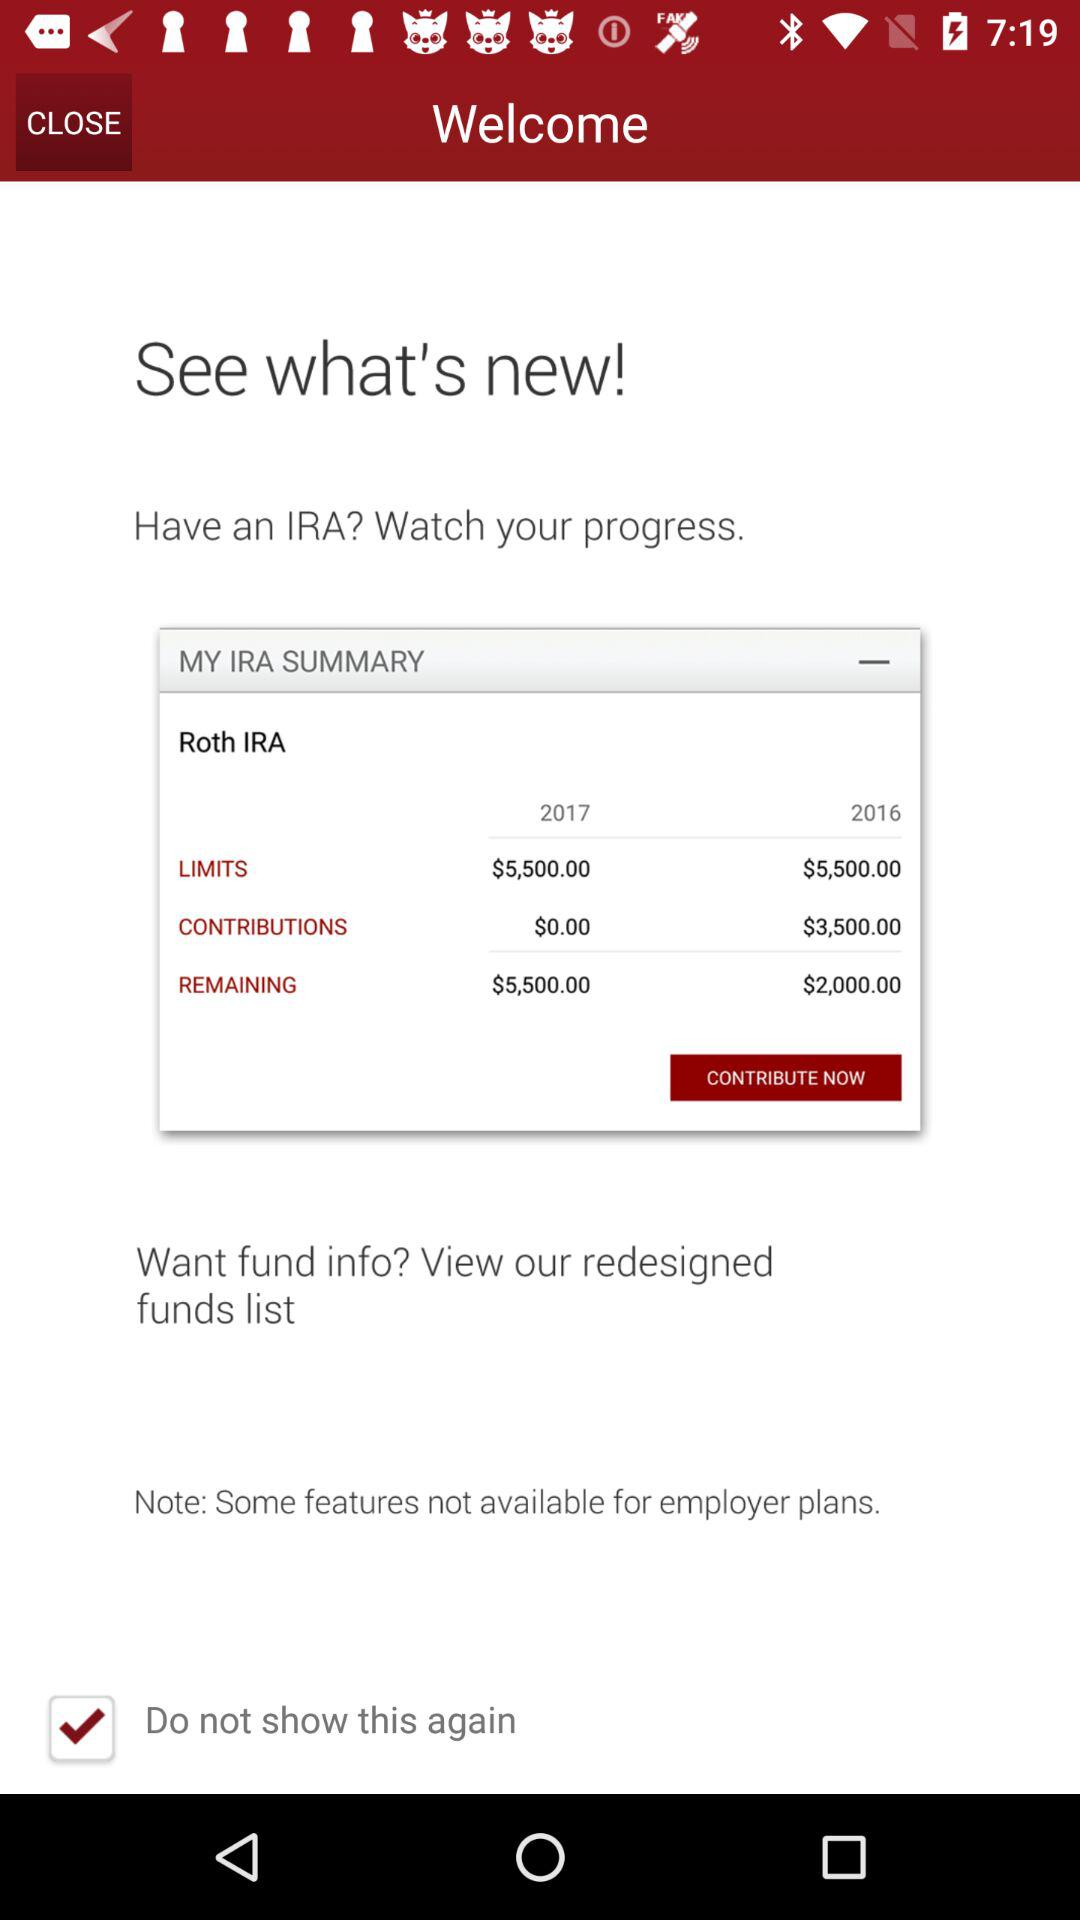What is the current status of "Do not show this again"? The current status of "Do not show this again" is "on". 